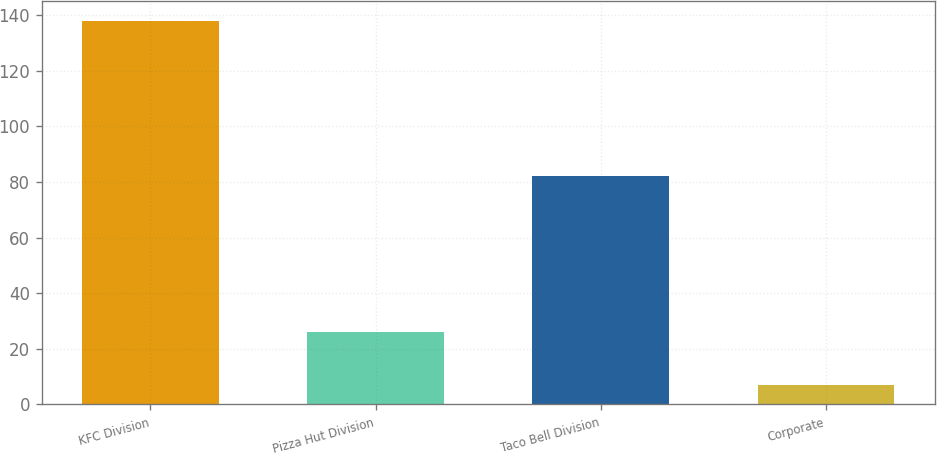Convert chart. <chart><loc_0><loc_0><loc_500><loc_500><bar_chart><fcel>KFC Division<fcel>Pizza Hut Division<fcel>Taco Bell Division<fcel>Corporate<nl><fcel>138<fcel>26<fcel>82<fcel>7<nl></chart> 